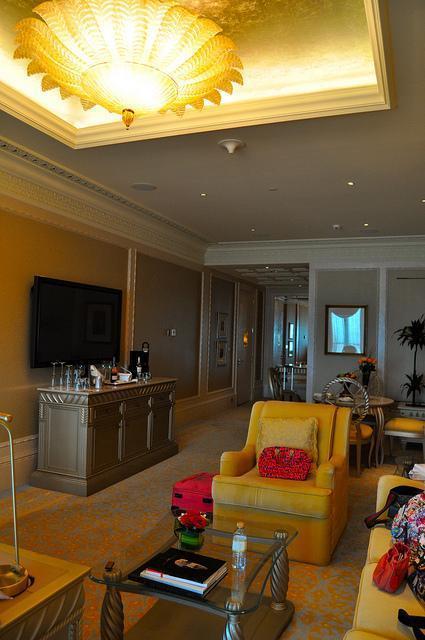How many couches are visible?
Give a very brief answer. 2. How many chairs are in the picture?
Give a very brief answer. 2. 